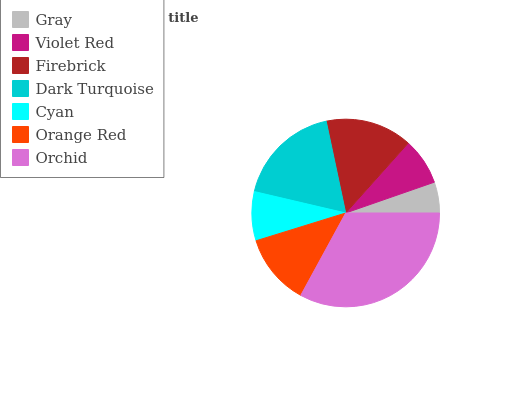Is Gray the minimum?
Answer yes or no. Yes. Is Orchid the maximum?
Answer yes or no. Yes. Is Violet Red the minimum?
Answer yes or no. No. Is Violet Red the maximum?
Answer yes or no. No. Is Violet Red greater than Gray?
Answer yes or no. Yes. Is Gray less than Violet Red?
Answer yes or no. Yes. Is Gray greater than Violet Red?
Answer yes or no. No. Is Violet Red less than Gray?
Answer yes or no. No. Is Orange Red the high median?
Answer yes or no. Yes. Is Orange Red the low median?
Answer yes or no. Yes. Is Gray the high median?
Answer yes or no. No. Is Cyan the low median?
Answer yes or no. No. 